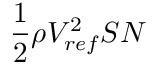Convert formula to latex. <formula><loc_0><loc_0><loc_500><loc_500>\frac { 1 } { 2 } \rho V _ { r e f } ^ { 2 } S N</formula> 